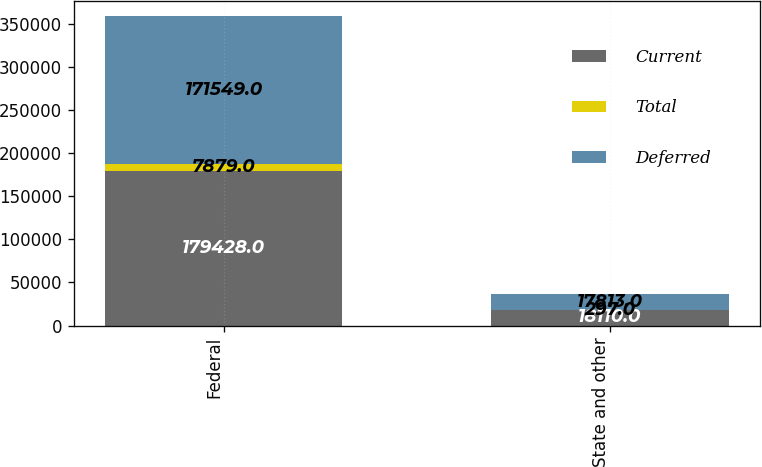Convert chart to OTSL. <chart><loc_0><loc_0><loc_500><loc_500><stacked_bar_chart><ecel><fcel>Federal<fcel>State and other<nl><fcel>Current<fcel>179428<fcel>18110<nl><fcel>Total<fcel>7879<fcel>297<nl><fcel>Deferred<fcel>171549<fcel>17813<nl></chart> 